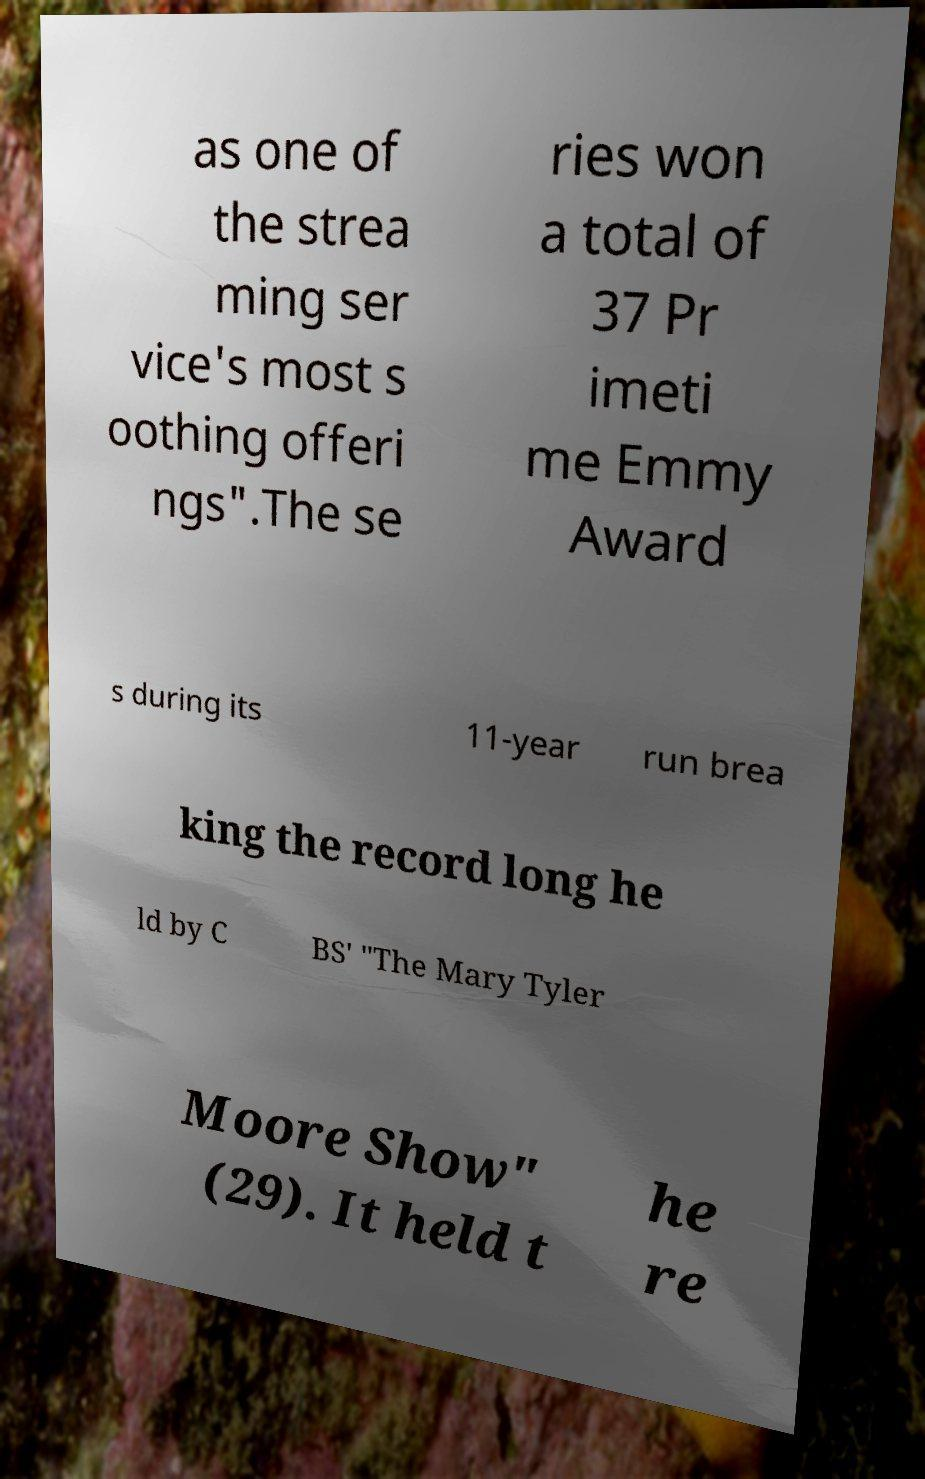Could you extract and type out the text from this image? as one of the strea ming ser vice's most s oothing offeri ngs".The se ries won a total of 37 Pr imeti me Emmy Award s during its 11-year run brea king the record long he ld by C BS' "The Mary Tyler Moore Show" (29). It held t he re 